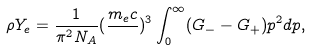<formula> <loc_0><loc_0><loc_500><loc_500>\rho Y _ { e } = \frac { 1 } { \pi ^ { 2 } N _ { A } } ( \frac { m _ { e } c } { } ) ^ { 3 } \int _ { 0 } ^ { \infty } ( G _ { - } - G _ { + } ) p ^ { 2 } d p ,</formula> 